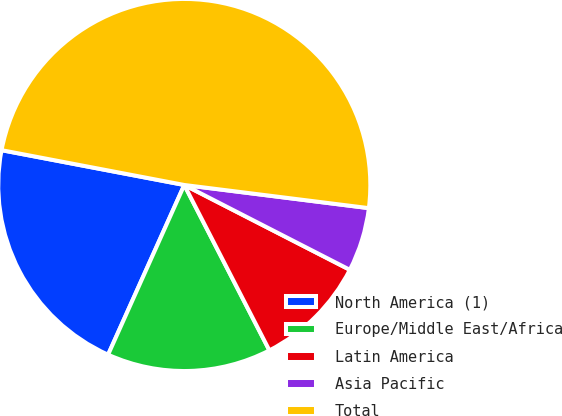Convert chart to OTSL. <chart><loc_0><loc_0><loc_500><loc_500><pie_chart><fcel>North America (1)<fcel>Europe/Middle East/Africa<fcel>Latin America<fcel>Asia Pacific<fcel>Total<nl><fcel>21.28%<fcel>14.28%<fcel>9.9%<fcel>5.55%<fcel>48.99%<nl></chart> 